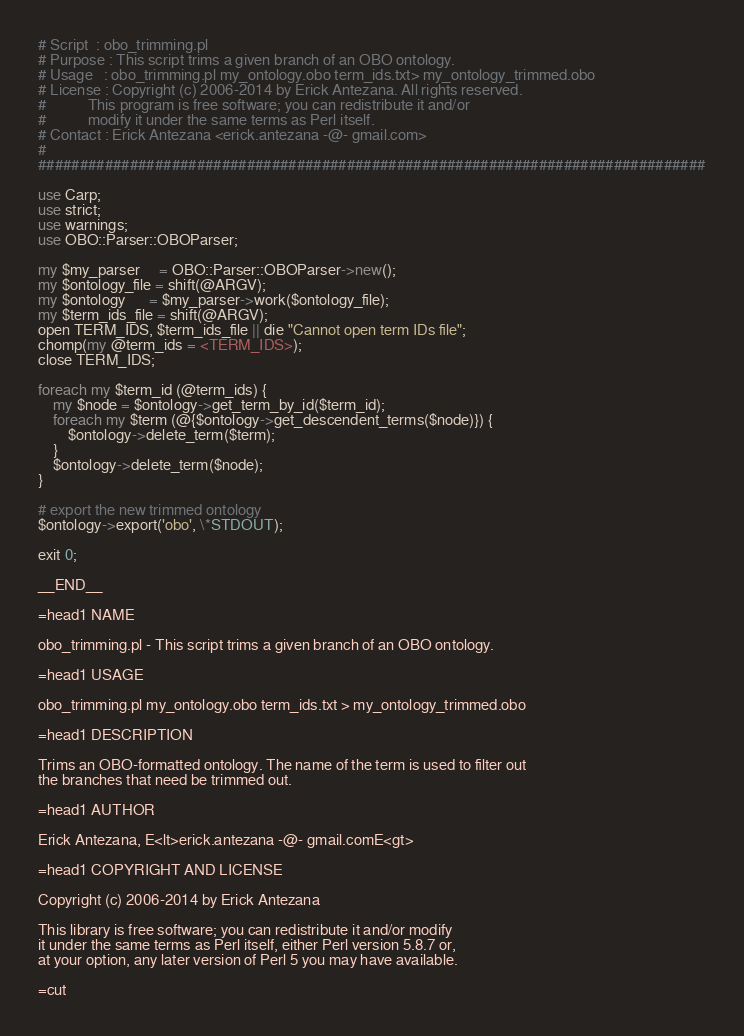Convert code to text. <code><loc_0><loc_0><loc_500><loc_500><_Perl_># Script  : obo_trimming.pl
# Purpose : This script trims a given branch of an OBO ontology.
# Usage   : obo_trimming.pl my_ontology.obo term_ids.txt> my_ontology_trimmed.obo
# License : Copyright (c) 2006-2014 by Erick Antezana. All rights reserved.
#           This program is free software; you can redistribute it and/or
#           modify it under the same terms as Perl itself.
# Contact : Erick Antezana <erick.antezana -@- gmail.com>
#
################################################################################

use Carp;
use strict;
use warnings;
use OBO::Parser::OBOParser;

my $my_parser     = OBO::Parser::OBOParser->new();
my $ontology_file = shift(@ARGV);
my $ontology      = $my_parser->work($ontology_file);
my $term_ids_file = shift(@ARGV);
open TERM_IDS, $term_ids_file || die "Cannot open term IDs file";
chomp(my @term_ids = <TERM_IDS>);
close TERM_IDS;

foreach my $term_id (@term_ids) {
	my $node = $ontology->get_term_by_id($term_id);
	foreach my $term (@{$ontology->get_descendent_terms($node)}) {
		$ontology->delete_term($term);
	}
	$ontology->delete_term($node);
}

# export the new trimmed ontology
$ontology->export('obo', \*STDOUT);

exit 0;

__END__

=head1 NAME

obo_trimming.pl - This script trims a given branch of an OBO ontology.

=head1 USAGE

obo_trimming.pl my_ontology.obo term_ids.txt > my_ontology_trimmed.obo

=head1 DESCRIPTION

Trims an OBO-formatted ontology. The name of the term is used to filter out 
the branches that need be trimmed out. 

=head1 AUTHOR

Erick Antezana, E<lt>erick.antezana -@- gmail.comE<gt>

=head1 COPYRIGHT AND LICENSE

Copyright (c) 2006-2014 by Erick Antezana

This library is free software; you can redistribute it and/or modify
it under the same terms as Perl itself, either Perl version 5.8.7 or,
at your option, any later version of Perl 5 you may have available.

=cut</code> 